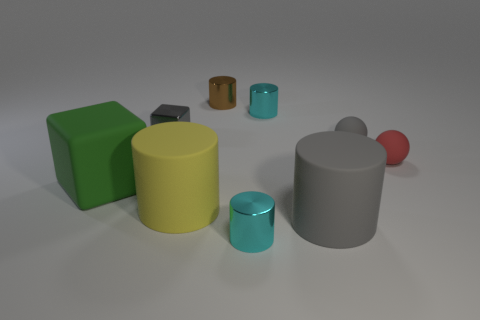Subtract all big gray cylinders. How many cylinders are left? 4 Subtract all brown balls. How many cyan cylinders are left? 2 Subtract all gray cylinders. How many cylinders are left? 4 Subtract 2 cylinders. How many cylinders are left? 3 Add 1 large green rubber cubes. How many objects exist? 10 Subtract all balls. How many objects are left? 7 Subtract all red cylinders. Subtract all purple spheres. How many cylinders are left? 5 Add 3 rubber cubes. How many rubber cubes are left? 4 Add 4 small brown spheres. How many small brown spheres exist? 4 Subtract 1 gray spheres. How many objects are left? 8 